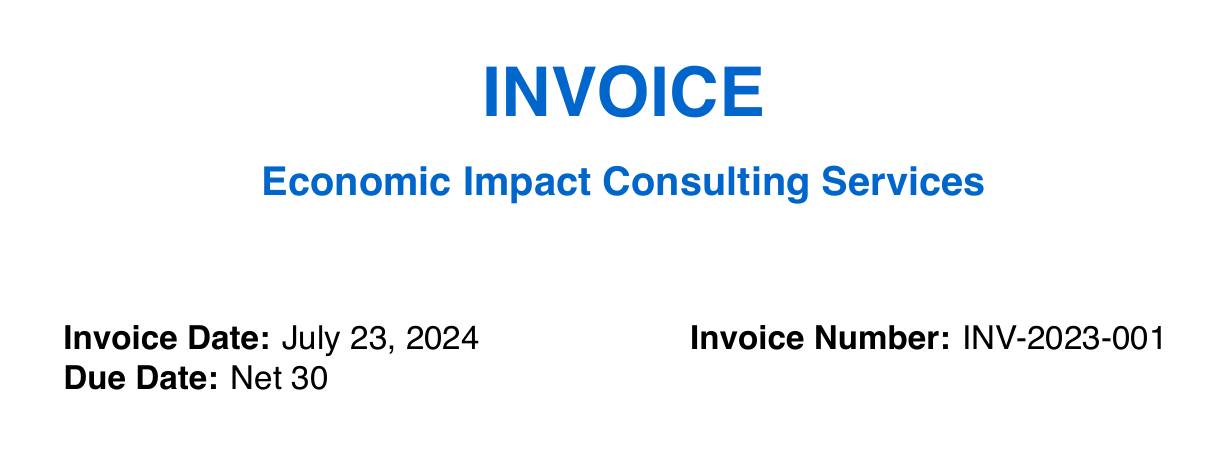What is the subtotal of the invoice? The subtotal is the total amount before tax, which is specified in the document.
Answer: $32,950 What is the total amount due? The total amount due is the sum of the subtotal and tax, which is clearly stated in the invoice.
Answer: $35,586 How many press releases are included? The quantity of press releases is indicated in the description of the service provided.
Answer: 5 releases What is the unit price for media training? The unit price for media training is specified in the invoice section listing all services.
Answer: $500 Who is the media training session for? The document specifies that the media training session is with Senator Johnson, mentioned in the service description.
Answer: Senator Johnson What is the tax rate applied to the invoice? The tax rate is mentioned clearly in the document next to the tax amount calculation.
Answer: 8% How many infographics are designed? The quantity of infographics is provided in the description of the infographic design service.
Answer: 3 infographics What type of campaign is included for LinkedIn? The invoice specifies the purpose of the LinkedIn advertising in the service description section.
Answer: Targeted advertising campaign What is the payment term specified in the invoice? The payment terms are explicitly stated in the corresponding section of the document.
Answer: Net 30 